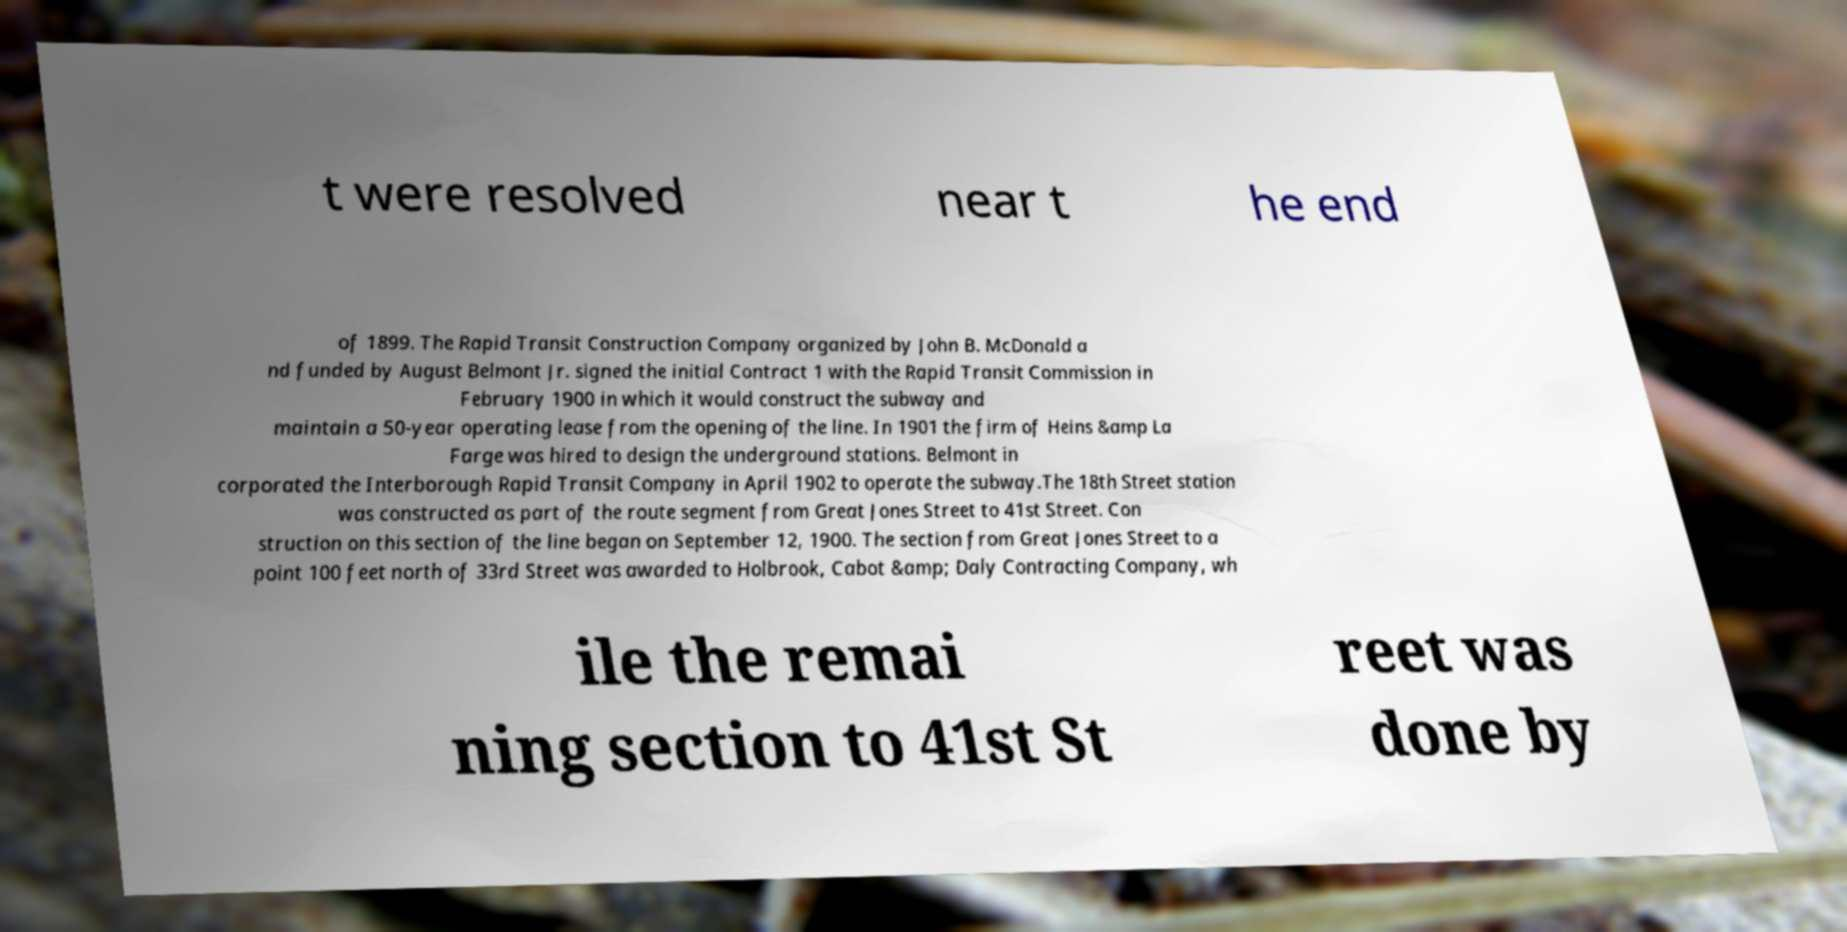For documentation purposes, I need the text within this image transcribed. Could you provide that? t were resolved near t he end of 1899. The Rapid Transit Construction Company organized by John B. McDonald a nd funded by August Belmont Jr. signed the initial Contract 1 with the Rapid Transit Commission in February 1900 in which it would construct the subway and maintain a 50-year operating lease from the opening of the line. In 1901 the firm of Heins &amp La Farge was hired to design the underground stations. Belmont in corporated the Interborough Rapid Transit Company in April 1902 to operate the subway.The 18th Street station was constructed as part of the route segment from Great Jones Street to 41st Street. Con struction on this section of the line began on September 12, 1900. The section from Great Jones Street to a point 100 feet north of 33rd Street was awarded to Holbrook, Cabot &amp; Daly Contracting Company, wh ile the remai ning section to 41st St reet was done by 